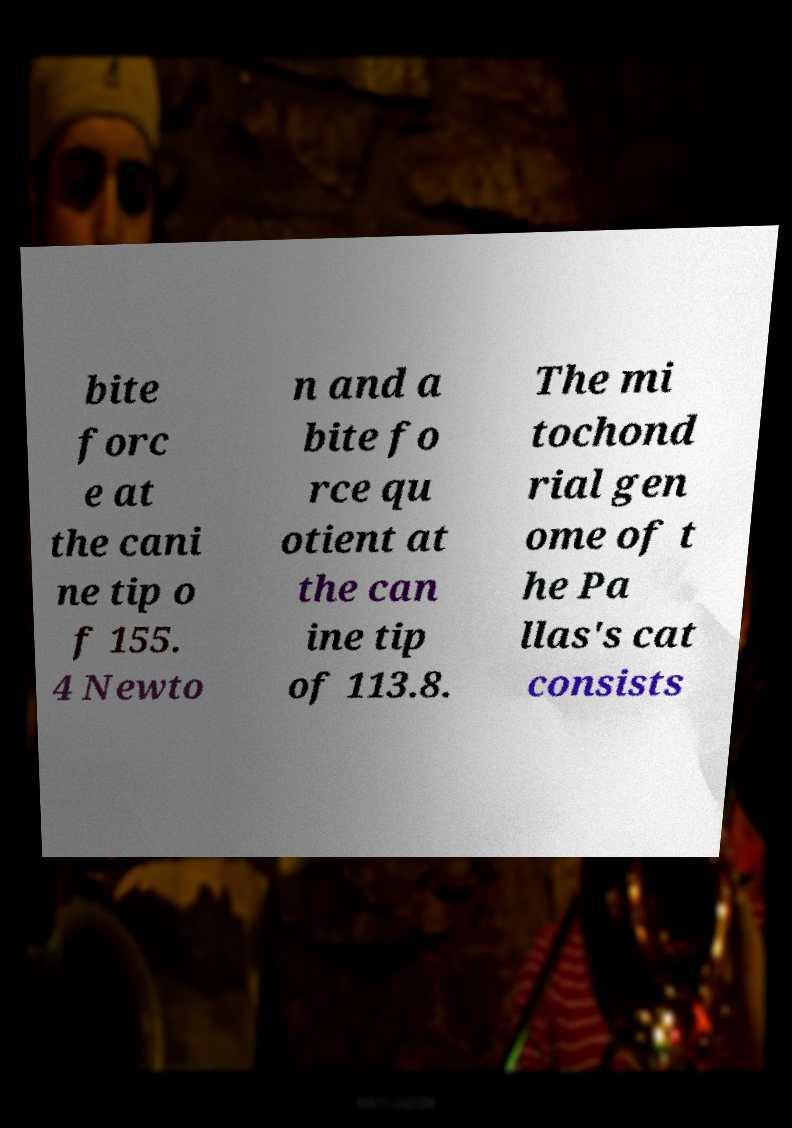Can you read and provide the text displayed in the image?This photo seems to have some interesting text. Can you extract and type it out for me? bite forc e at the cani ne tip o f 155. 4 Newto n and a bite fo rce qu otient at the can ine tip of 113.8. The mi tochond rial gen ome of t he Pa llas's cat consists 